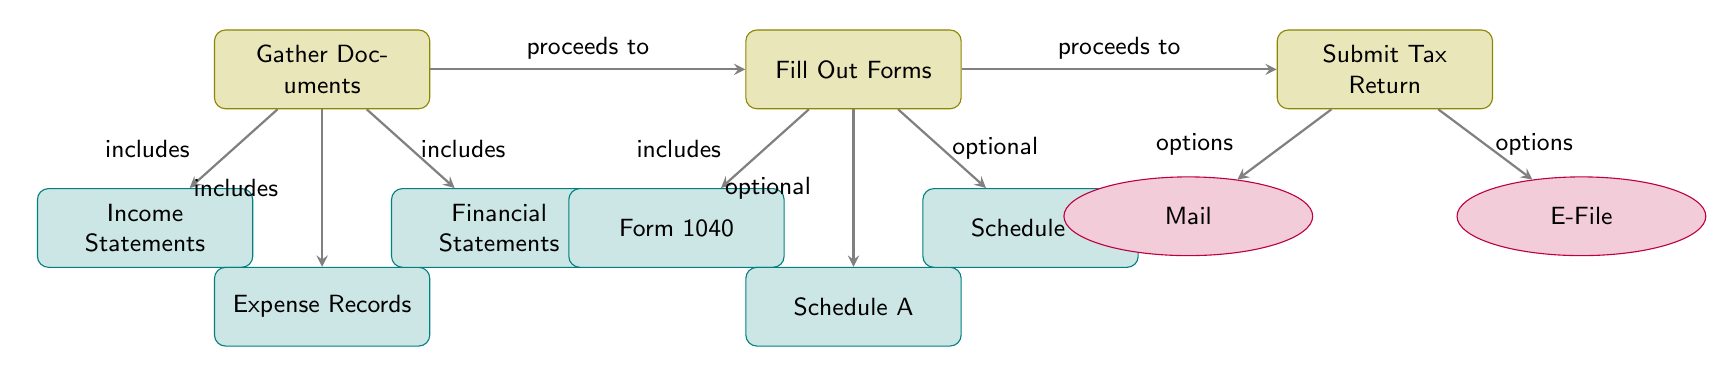What is the first step in filing a tax return? The first step in the diagram is "Gather Documents." It is the initial process node displayed at the top left of the diagram.
Answer: Gather Documents How many types of documents are included in the "Gather Documents" step? In the "Gather Documents" step, there are three types of documents listed: Income Statements, Expense Records, and Financial Statements. Counting these provides a total of three types.
Answer: 3 What is the form required in the "Fill Out Forms" step? The diagram specifies that "Form 1040" is included in the "Fill Out Forms" step. It is the first document shown under this process in the diagram.
Answer: Form 1040 What options are available for submitting the tax return? The diagram lists two options for submitting the tax return: "Mail" and "E-File." These options are shown as nodes branching from the "Submit Tax Return" process.
Answer: Mail, E-File Which step proceeds after gathering documents? After the "Gather Documents" step, the next step in the process is "Fill Out Forms." This is indicated by the arrow connecting these two steps in the diagram.
Answer: Fill Out Forms What documents are considered optional in the "Fill Out Forms" stage? In the "Fill Out Forms" stage, the optional documents listed are "Schedule A" and "Schedule C." Both are shown as documents branching from the "Fill Out Forms" process in the diagram.
Answer: Schedule A, Schedule C What is the last step in the tax filing process? The last step shown in the diagram is "Submit Tax Return." It follows the "Fill Out Forms" step and is the concluding process node in the flow.
Answer: Submit Tax Return What does the "Gather Documents" step include? The "Gather Documents" step includes three types of documents: "Income Statements," "Expense Records," and "Financial Statements." These are depicted as sources of information contributing to this step in the diagram.
Answer: Income Statements, Expense Records, Financial Statements 